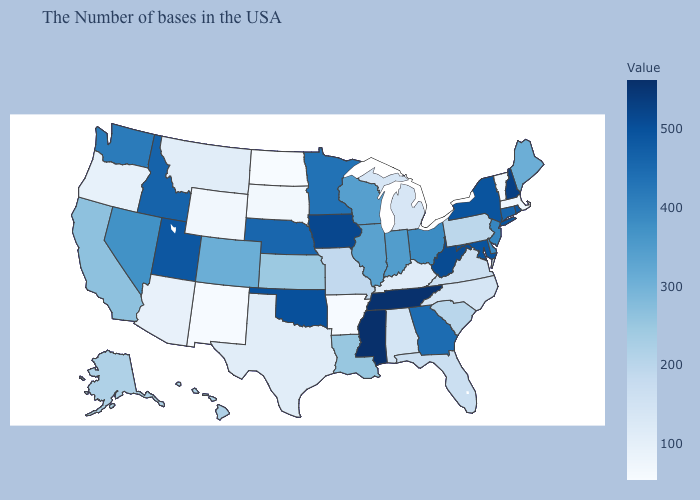Among the states that border Georgia , does North Carolina have the lowest value?
Keep it brief. Yes. Which states have the highest value in the USA?
Write a very short answer. Mississippi. Among the states that border Ohio , which have the lowest value?
Keep it brief. Kentucky. Which states hav the highest value in the West?
Be succinct. Utah. Is the legend a continuous bar?
Keep it brief. Yes. Does Virginia have a higher value than Texas?
Quick response, please. Yes. 